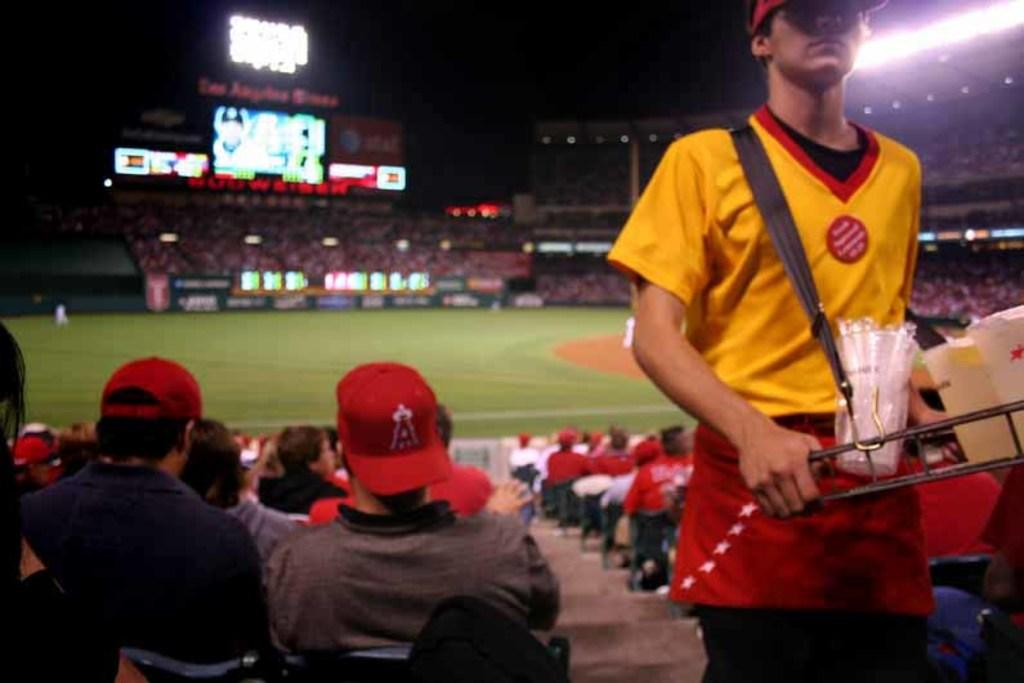<image>
Write a terse but informative summary of the picture. The backwards cap worn by a spectator at a ball game has a red letter A on it. 